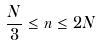Convert formula to latex. <formula><loc_0><loc_0><loc_500><loc_500>\frac { N } { 3 } \leq n \leq 2 N</formula> 